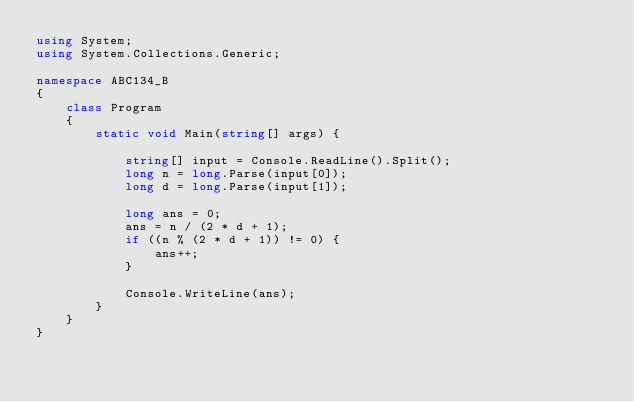Convert code to text. <code><loc_0><loc_0><loc_500><loc_500><_C#_>using System;
using System.Collections.Generic;

namespace ABC134_B
{
    class Program
    {
        static void Main(string[] args) {
            
            string[] input = Console.ReadLine().Split();
            long n = long.Parse(input[0]);
            long d = long.Parse(input[1]);

            long ans = 0;
            ans = n / (2 * d + 1);
            if ((n % (2 * d + 1)) != 0) {
                ans++;
            }

            Console.WriteLine(ans);
        }
    }
}</code> 